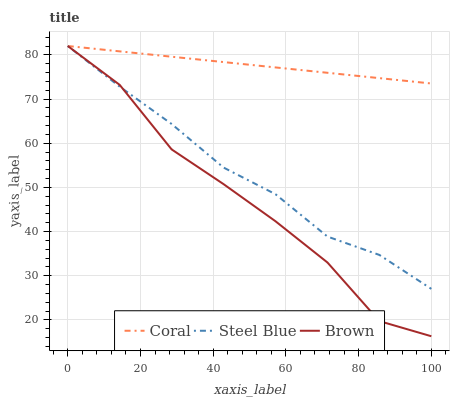Does Brown have the minimum area under the curve?
Answer yes or no. Yes. Does Coral have the maximum area under the curve?
Answer yes or no. Yes. Does Steel Blue have the minimum area under the curve?
Answer yes or no. No. Does Steel Blue have the maximum area under the curve?
Answer yes or no. No. Is Coral the smoothest?
Answer yes or no. Yes. Is Brown the roughest?
Answer yes or no. Yes. Is Steel Blue the smoothest?
Answer yes or no. No. Is Steel Blue the roughest?
Answer yes or no. No. Does Brown have the lowest value?
Answer yes or no. Yes. Does Steel Blue have the lowest value?
Answer yes or no. No. Does Steel Blue have the highest value?
Answer yes or no. Yes. Does Brown intersect Coral?
Answer yes or no. Yes. Is Brown less than Coral?
Answer yes or no. No. Is Brown greater than Coral?
Answer yes or no. No. 